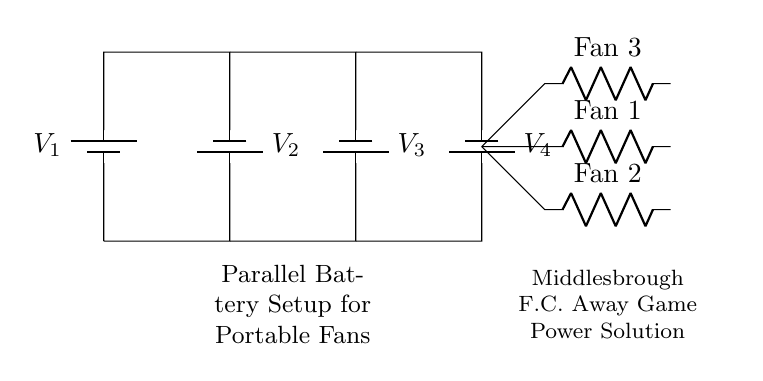What type of circuit is shown? The circuit is a parallel circuit as indicated by the arrangement of the batteries and loads. In a parallel setup, the components are connected across the same voltage source, allowing each load to operate independently.
Answer: Parallel How many batteries are connected? There are four batteries connected in the circuit, as shown by the four battery symbols labeled V1, V2, V3, and V4. Each battery contributes to the power supply for the connected loads.
Answer: Four What are the connected loads? The loads connected are three fans, labeled as Fan 1, Fan 2, and Fan 3. They are connected across the parallel battery setup, which allows them to operate simultaneously.
Answer: Three fans What is the voltage provided to the fans? The voltage provided to the fans is determined by the voltage of the batteries connected in parallel, which is the same as the voltage of each battery used, since all batteries are assumed to have the same voltage rating.
Answer: Same as battery voltage Why use a parallel configuration for the fans? A parallel configuration is used for the fans to ensure that each fan receives the same voltage and can operate independently. This allows for continued operation of the other fans if one fails, and efficient usage of battery capacity.
Answer: To ensure independent operation What happens if one battery fails? If one battery fails in a parallel circuit, the remaining batteries will still supply voltage to the loads, allowing them to continue functioning. This is a key advantage of the parallel configuration.
Answer: Remaining batteries supply voltage 